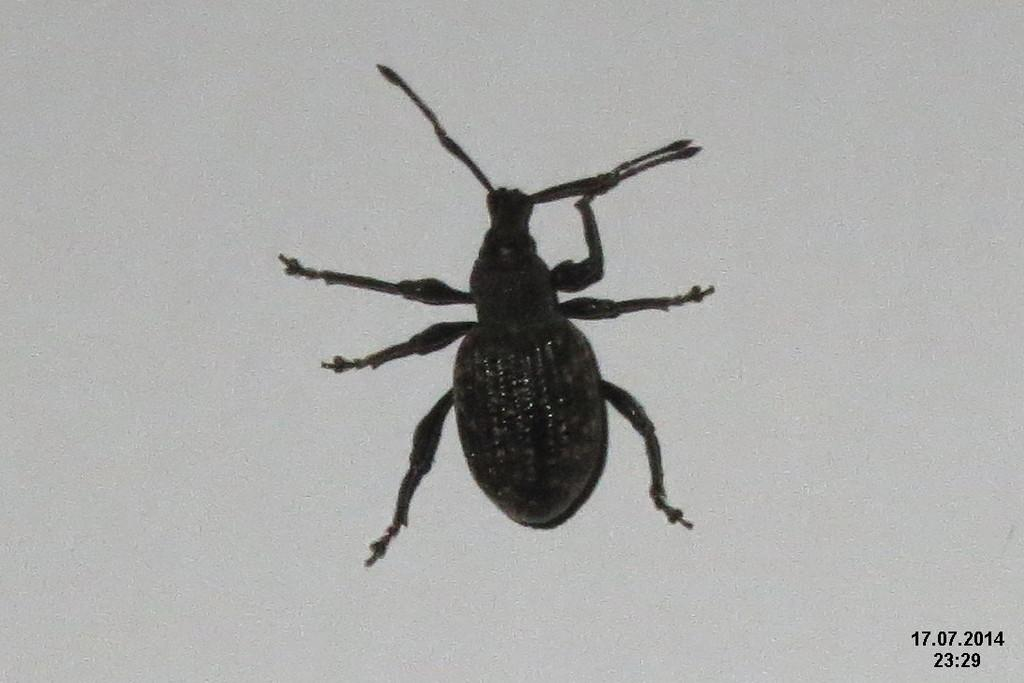What type of creature can be seen in the image? There is an insect in the image. Where is the insect located? The insect is on a surface in the image. Is there any text present in the image? Yes, there is text in the bottom right corner of the image. What type of cloth is being used to carry the bucket in the image? There is no bucket or cloth present in the image; it only features an insect on a surface and text in the bottom right corner. 